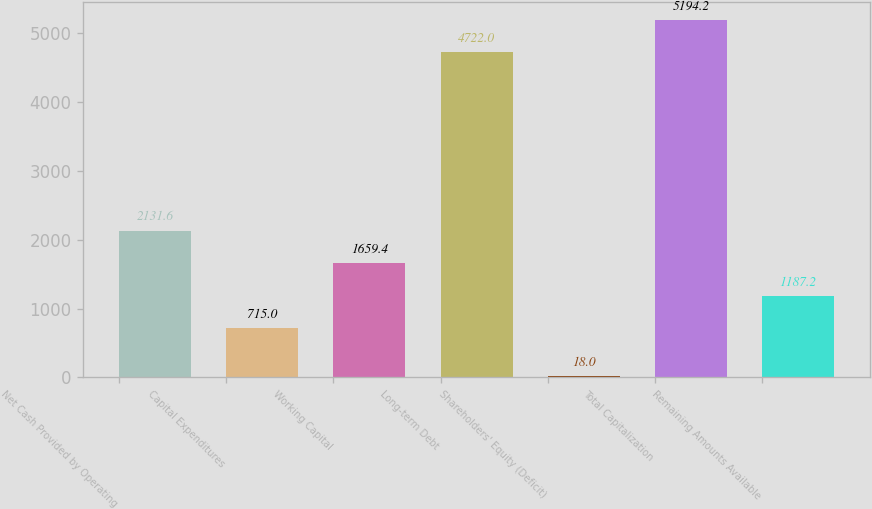Convert chart. <chart><loc_0><loc_0><loc_500><loc_500><bar_chart><fcel>Net Cash Provided by Operating<fcel>Capital Expenditures<fcel>Working Capital<fcel>Long-term Debt<fcel>Shareholders' Equity (Deficit)<fcel>Total Capitalization<fcel>Remaining Amounts Available<nl><fcel>2131.6<fcel>715<fcel>1659.4<fcel>4722<fcel>18<fcel>5194.2<fcel>1187.2<nl></chart> 